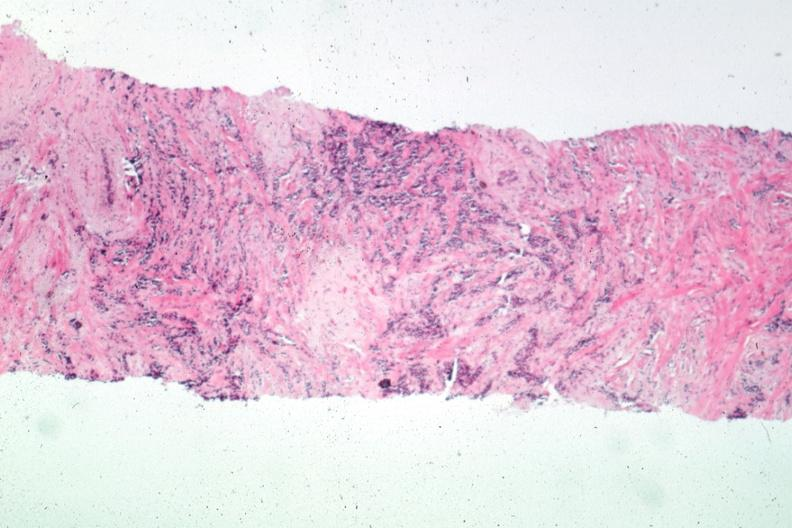does anencephaly show needle biopsy with obvious carcinoma?
Answer the question using a single word or phrase. No 